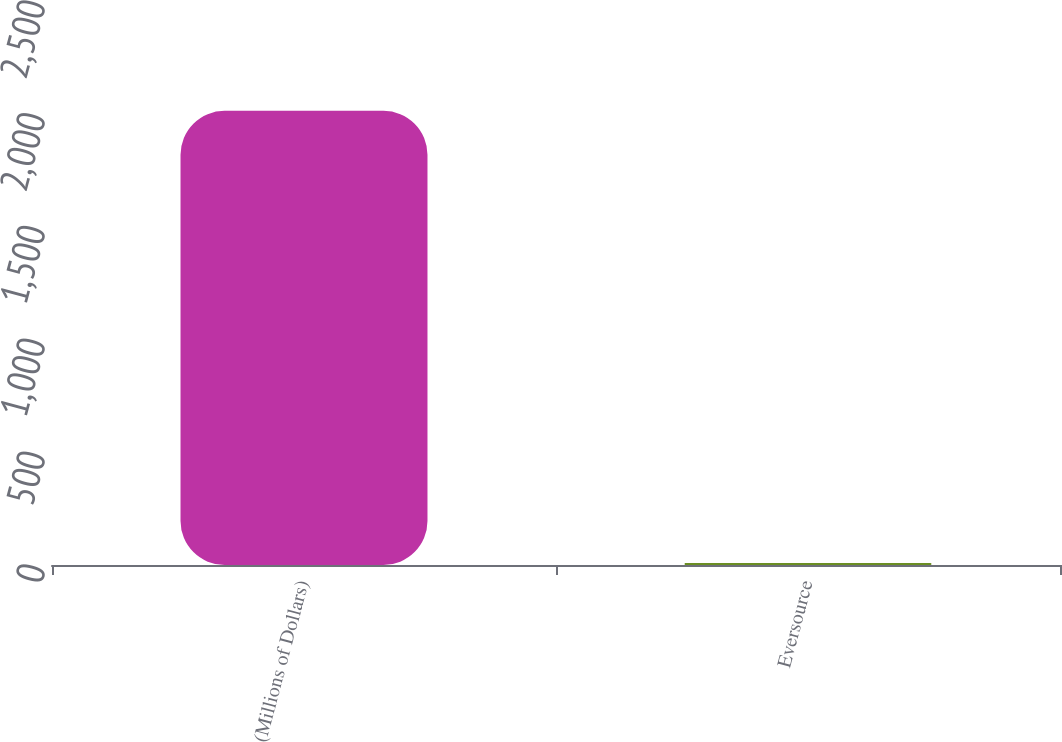Convert chart. <chart><loc_0><loc_0><loc_500><loc_500><bar_chart><fcel>(Millions of Dollars)<fcel>Eversource<nl><fcel>2013<fcel>8.6<nl></chart> 